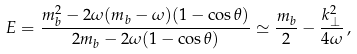<formula> <loc_0><loc_0><loc_500><loc_500>E = \frac { m _ { b } ^ { 2 } - 2 \omega ( m _ { b } - \omega ) ( 1 - \cos { \theta } ) } { 2 m _ { b } - 2 \omega ( 1 - \cos { \theta } ) } \simeq \frac { m _ { b } } { 2 } - \frac { k _ { \perp } ^ { 2 } } { 4 \omega } \, ,</formula> 